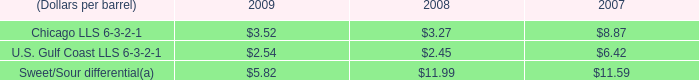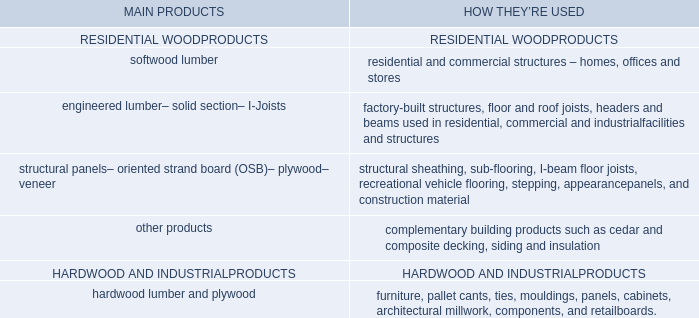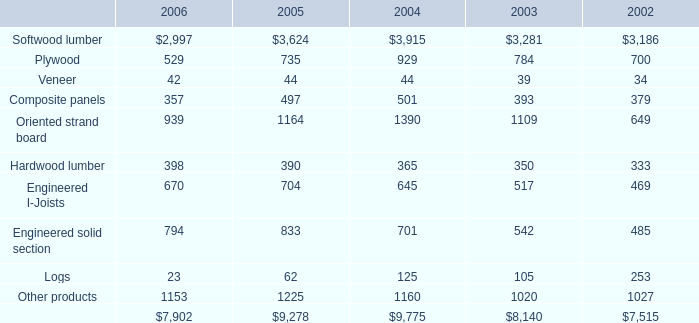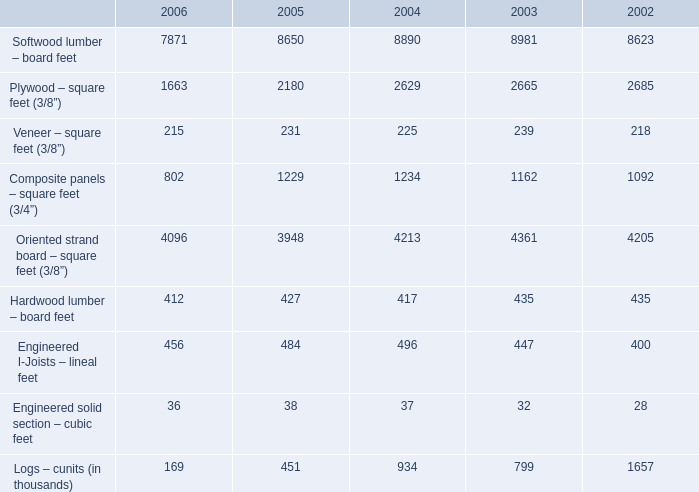by what percentage did the average crack spread for the midwest ( chicago ) decrease from 2007 to 2009? 
Computations: ((3.52 - 8.87) / 8.87)
Answer: -0.60316. 